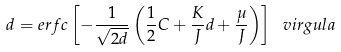Convert formula to latex. <formula><loc_0><loc_0><loc_500><loc_500>d = e r f c \left [ - \frac { 1 } { \sqrt { 2 d } } \left ( \frac { 1 } { 2 } C + \frac { K } { J } d + \frac { \mu } { J } \right ) \right ] \ v i r g u l a</formula> 